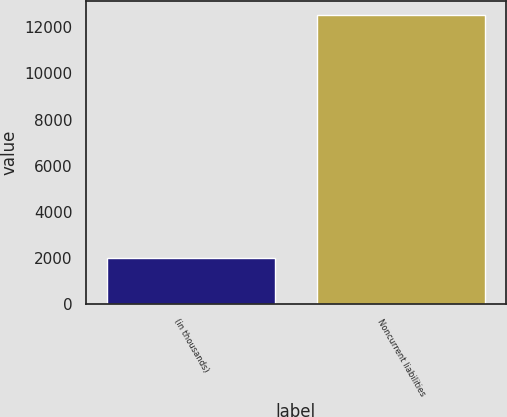Convert chart. <chart><loc_0><loc_0><loc_500><loc_500><bar_chart><fcel>(in thousands)<fcel>Noncurrent liabilities<nl><fcel>2010<fcel>12515<nl></chart> 